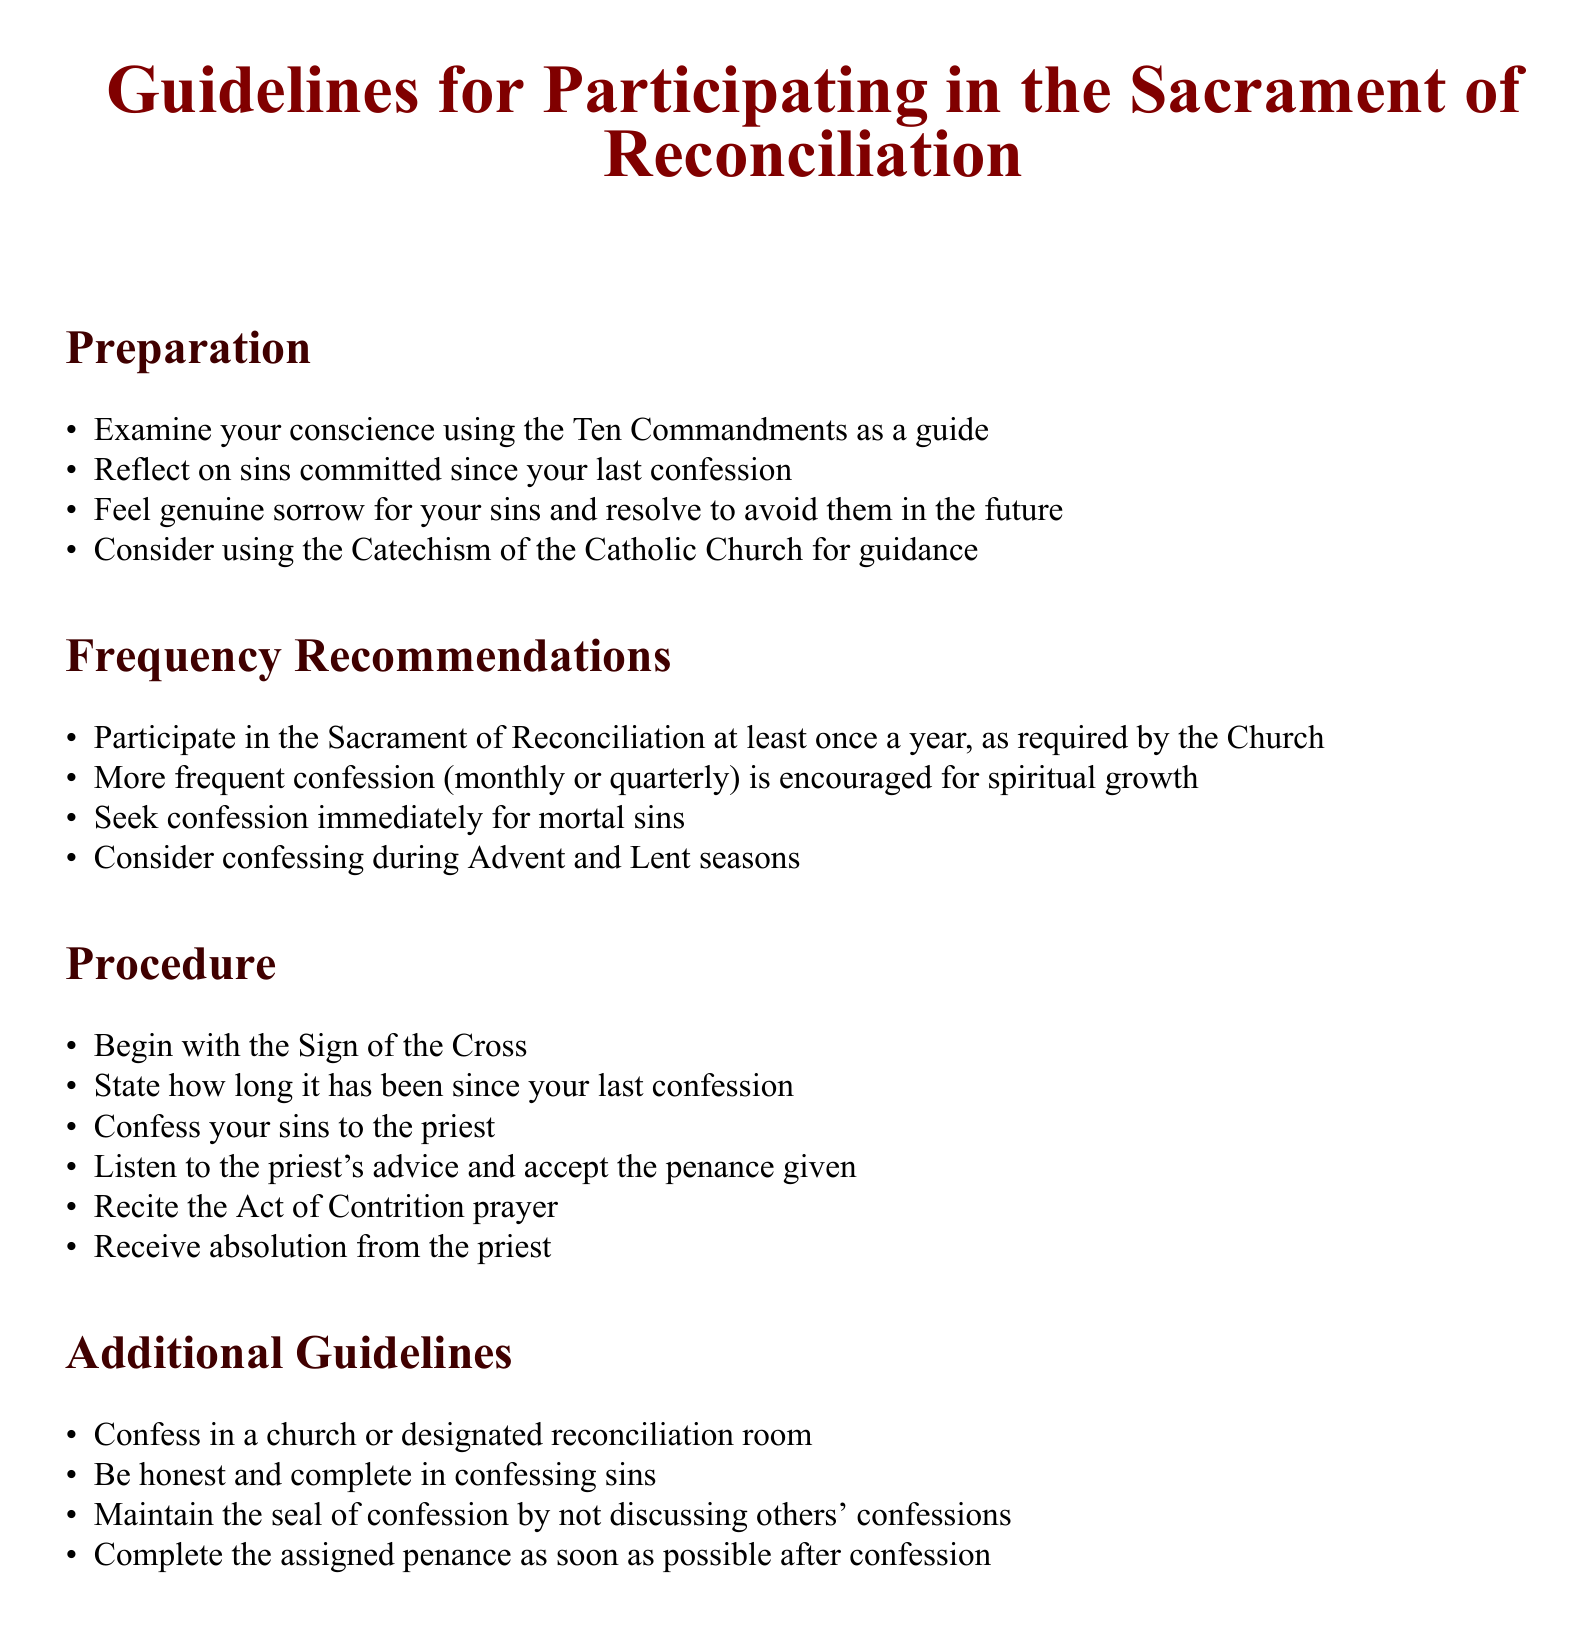What is the purpose of the guidelines? The guidelines provide instructions on how to participate in the Sacrament of Reconciliation.
Answer: instructions on how to participate in the Sacrament of Reconciliation What must one examine during preparation? The document specifies that one should examine their conscience as part of the preparation for confession.
Answer: conscience How often should one participate in the Sacrament of Reconciliation at a minimum? The guidelines state that participation at least once a year is required by the Church.
Answer: once a year What prayer should be recited after confessing sins? The guidelines mention the Act of Contrition prayer should be recited after confessing.
Answer: Act of Contrition What should be done immediately after committing a mortal sin? The document advises seeking confession immediately for mortal sins.
Answer: seeking confession What is one season during which it is suggested to confess? The guidelines recommend considering confession during Advent.
Answer: Advent What should be maintained during confession? The document emphasizes the importance of maintaining the seal of confession.
Answer: seal of confession How long should you state it has been since your last confession? The guidelines instruct participants to mention how long it has been since their last confession.
Answer: how long it has been What room is suggested for confession? The document states to confess in a church or designated reconciliation room.
Answer: church or designated reconciliation room 